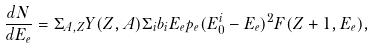Convert formula to latex. <formula><loc_0><loc_0><loc_500><loc_500>\frac { d N } { d E _ { e } } = \Sigma _ { A , Z } Y ( Z , A ) \Sigma _ { i } b _ { i } E _ { e } p _ { e } ( E _ { 0 } ^ { i } - E _ { e } ) ^ { 2 } F ( Z + 1 , E _ { e } ) ,</formula> 